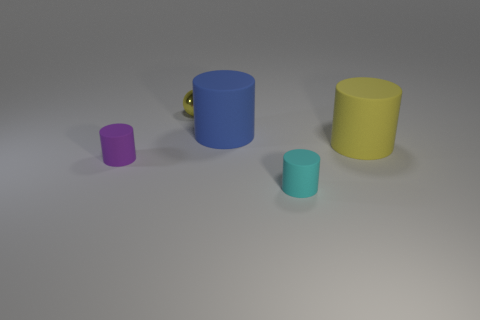Is there anything else that is made of the same material as the tiny yellow sphere?
Your response must be concise. No. Are there any cubes?
Your answer should be compact. No. There is a sphere; are there any things right of it?
Offer a very short reply. Yes. Is the big thing that is on the left side of the large yellow matte thing made of the same material as the large yellow object?
Offer a very short reply. Yes. Is there another thing of the same color as the shiny object?
Provide a succinct answer. Yes. There is a purple object; what shape is it?
Ensure brevity in your answer.  Cylinder. What color is the tiny rubber thing on the right side of the tiny thing behind the small purple cylinder?
Your response must be concise. Cyan. What is the size of the yellow metallic object on the left side of the big yellow rubber cylinder?
Give a very brief answer. Small. Is there a big yellow thing made of the same material as the purple thing?
Your answer should be compact. Yes. How many big matte things have the same shape as the metallic thing?
Ensure brevity in your answer.  0. 